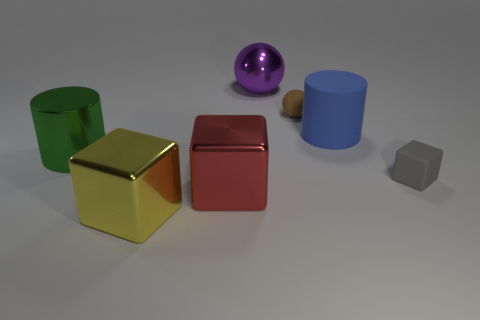Is the yellow thing made of the same material as the large purple ball?
Keep it short and to the point. Yes. There is a metallic cube in front of the big red block; is its size the same as the metallic cube that is to the right of the big yellow block?
Give a very brief answer. Yes. Is the number of yellow things less than the number of yellow rubber spheres?
Offer a terse response. No. How many metallic things are either tiny gray objects or big things?
Give a very brief answer. 4. Are there any yellow shiny things that are behind the small rubber thing that is to the left of the gray matte cube?
Provide a short and direct response. No. Is the object in front of the large red metallic thing made of the same material as the red thing?
Your answer should be compact. Yes. What number of other things are there of the same color as the rubber ball?
Your answer should be very brief. 0. Do the big ball and the rubber cylinder have the same color?
Your answer should be very brief. No. There is a cube to the right of the sphere on the right side of the big purple shiny thing; how big is it?
Keep it short and to the point. Small. Is the large cylinder that is to the right of the big yellow cube made of the same material as the small thing that is to the left of the gray object?
Keep it short and to the point. Yes. 